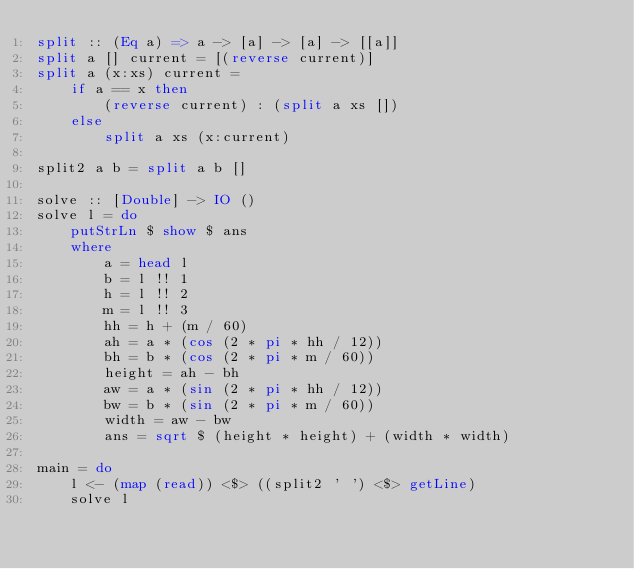<code> <loc_0><loc_0><loc_500><loc_500><_Haskell_>split :: (Eq a) => a -> [a] -> [a] -> [[a]]
split a [] current = [(reverse current)]
split a (x:xs) current =
    if a == x then
        (reverse current) : (split a xs [])
    else
        split a xs (x:current)
        
split2 a b = split a b []

solve :: [Double] -> IO ()
solve l = do
    putStrLn $ show $ ans
    where
        a = head l
        b = l !! 1
        h = l !! 2
        m = l !! 3
        hh = h + (m / 60)
        ah = a * (cos (2 * pi * hh / 12))
        bh = b * (cos (2 * pi * m / 60))
        height = ah - bh
        aw = a * (sin (2 * pi * hh / 12))
        bw = b * (sin (2 * pi * m / 60))
        width = aw - bw
        ans = sqrt $ (height * height) + (width * width)

main = do
    l <- (map (read)) <$> ((split2 ' ') <$> getLine)
    solve l</code> 